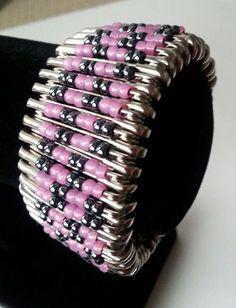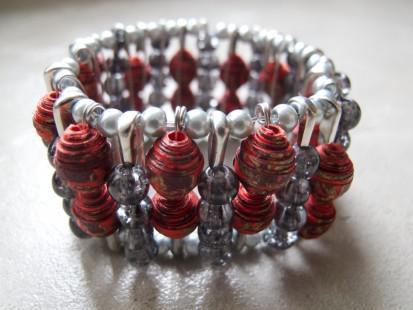The first image is the image on the left, the second image is the image on the right. Analyze the images presented: Is the assertion "the beads hanging from the safety pin to the left are mostly purple and blue" valid? Answer yes or no. No. The first image is the image on the left, the second image is the image on the right. Given the left and right images, does the statement "One image shows a safety pin bracelet displayed on a flat surface, and the other image shows a safety pin strung with colored beads that form an animal image." hold true? Answer yes or no. No. 